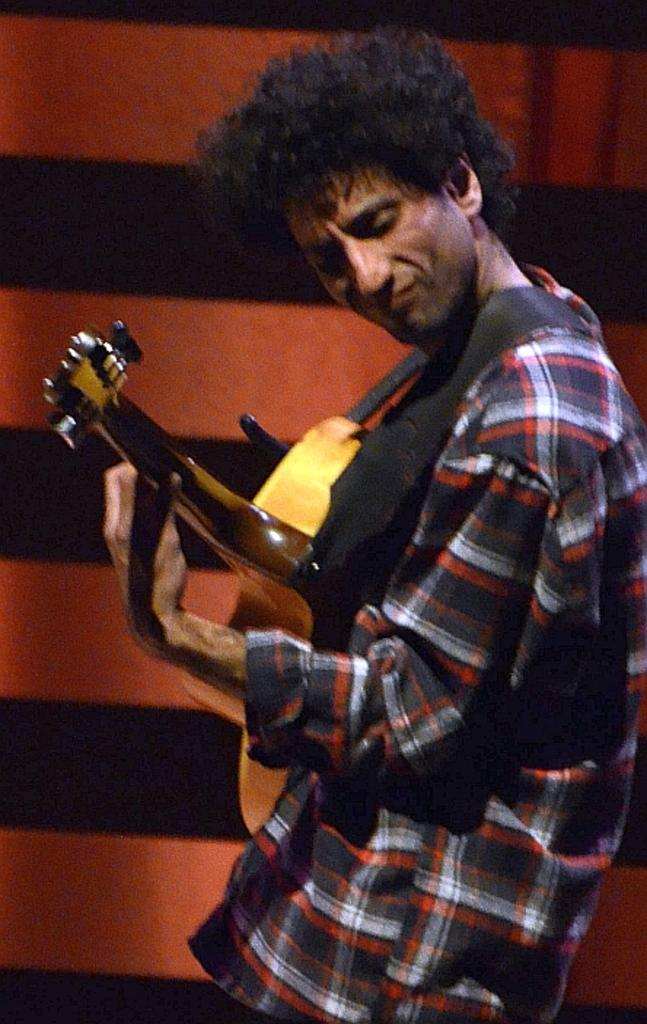What is the main subject of the image? The main subject of the image is a man. What is the man wearing in the image? The man is wearing a check shirt. What activity is the man engaged in? The man is playing a guitar. Can you describe the background of the image? There is an orange and black color wall in the background of the image. What type of juice can be seen in the man's hand in the image? There is no juice present in the image; the man is playing a guitar. What is the man saying good-bye to in the image? There is no indication in the image that the man is saying good-bye to anyone or anything. 